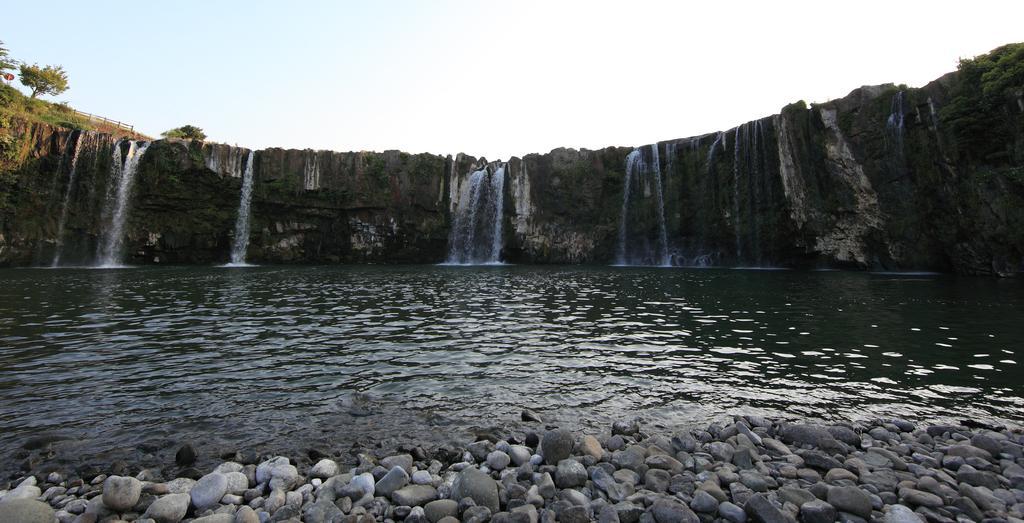Could you give a brief overview of what you see in this image? In the picture I can see stones, water, waterfall, fence, trees and the plain sky in the background. 